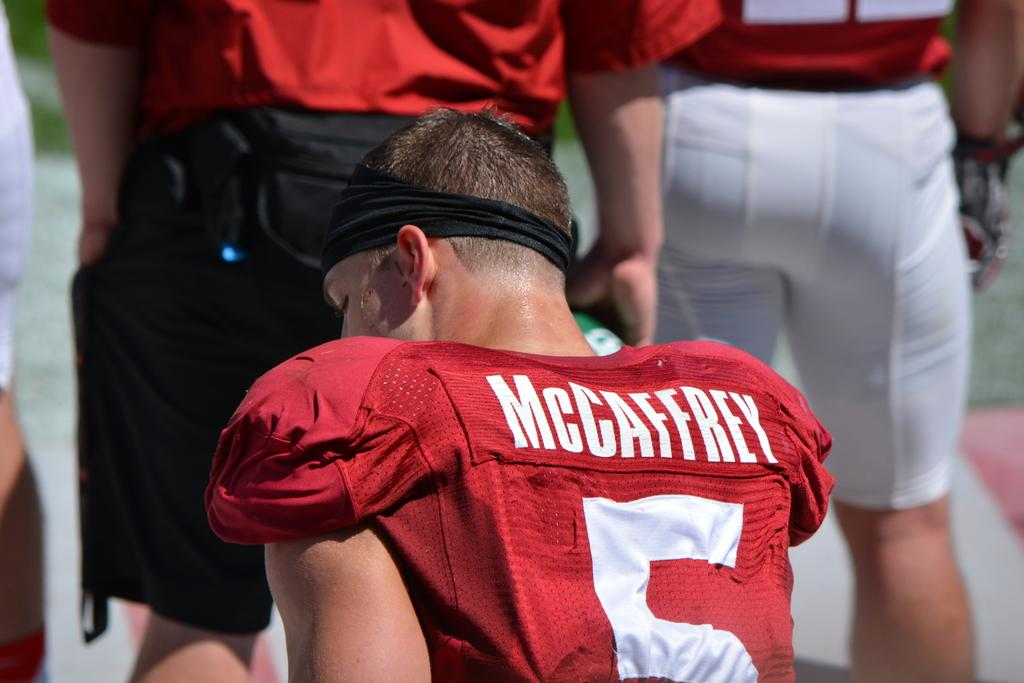<image>
Render a clear and concise summary of the photo. A football player with the name McCaffrey on his jersey. 